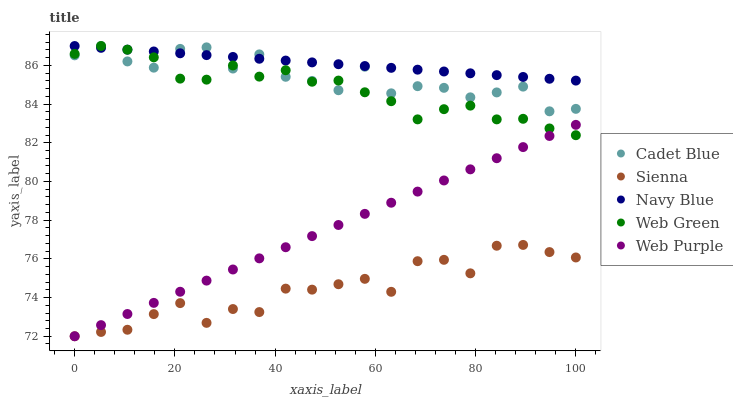Does Sienna have the minimum area under the curve?
Answer yes or no. Yes. Does Navy Blue have the maximum area under the curve?
Answer yes or no. Yes. Does Web Purple have the minimum area under the curve?
Answer yes or no. No. Does Web Purple have the maximum area under the curve?
Answer yes or no. No. Is Navy Blue the smoothest?
Answer yes or no. Yes. Is Cadet Blue the roughest?
Answer yes or no. Yes. Is Web Purple the smoothest?
Answer yes or no. No. Is Web Purple the roughest?
Answer yes or no. No. Does Sienna have the lowest value?
Answer yes or no. Yes. Does Navy Blue have the lowest value?
Answer yes or no. No. Does Web Green have the highest value?
Answer yes or no. Yes. Does Web Purple have the highest value?
Answer yes or no. No. Is Web Purple less than Cadet Blue?
Answer yes or no. Yes. Is Cadet Blue greater than Web Purple?
Answer yes or no. Yes. Does Web Purple intersect Sienna?
Answer yes or no. Yes. Is Web Purple less than Sienna?
Answer yes or no. No. Is Web Purple greater than Sienna?
Answer yes or no. No. Does Web Purple intersect Cadet Blue?
Answer yes or no. No. 